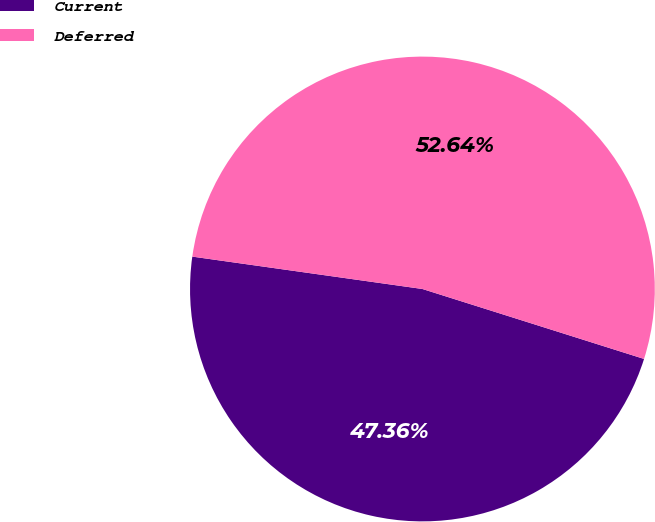<chart> <loc_0><loc_0><loc_500><loc_500><pie_chart><fcel>Current<fcel>Deferred<nl><fcel>47.36%<fcel>52.64%<nl></chart> 